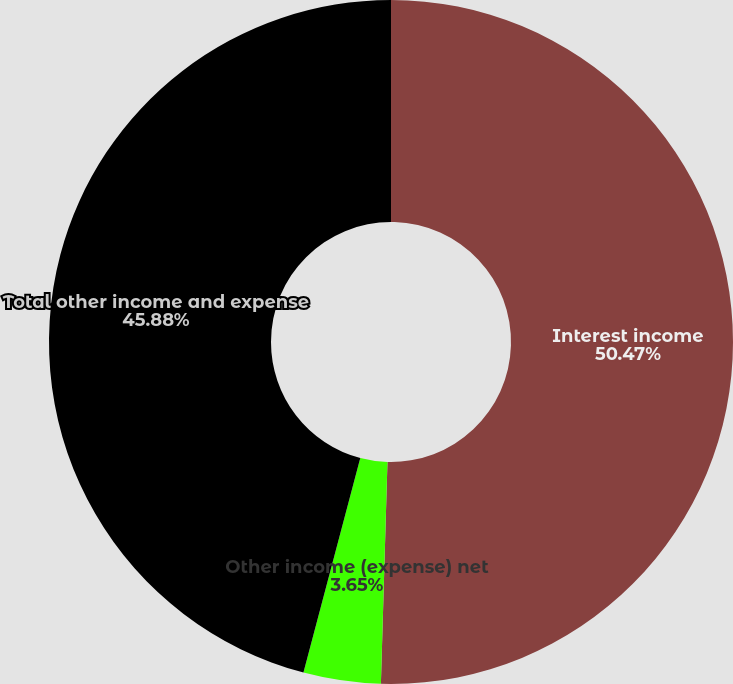Convert chart. <chart><loc_0><loc_0><loc_500><loc_500><pie_chart><fcel>Interest income<fcel>Other income (expense) net<fcel>Total other income and expense<nl><fcel>50.47%<fcel>3.65%<fcel>45.88%<nl></chart> 